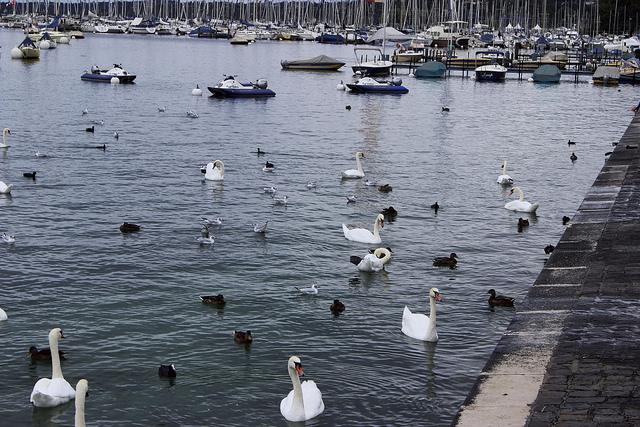What is in the water?
Answer briefly. Ducks. What kind of birds are swimming in the bay?
Short answer required. Swans and ducks. How many geese are there?
Give a very brief answer. 0. 